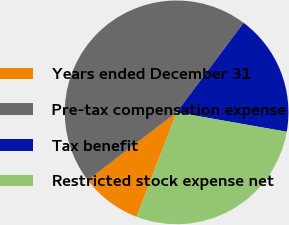Convert chart to OTSL. <chart><loc_0><loc_0><loc_500><loc_500><pie_chart><fcel>Years ended December 31<fcel>Pre-tax compensation expense<fcel>Tax benefit<fcel>Restricted stock expense net<nl><fcel>8.8%<fcel>45.6%<fcel>17.55%<fcel>28.04%<nl></chart> 